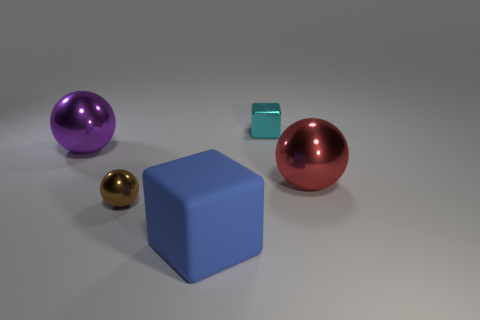Add 2 big blocks. How many objects exist? 7 Subtract all spheres. How many objects are left? 2 Subtract 0 yellow cubes. How many objects are left? 5 Subtract all large blue matte cubes. Subtract all big purple shiny objects. How many objects are left? 3 Add 2 small brown metal spheres. How many small brown metal spheres are left? 3 Add 3 blue cubes. How many blue cubes exist? 4 